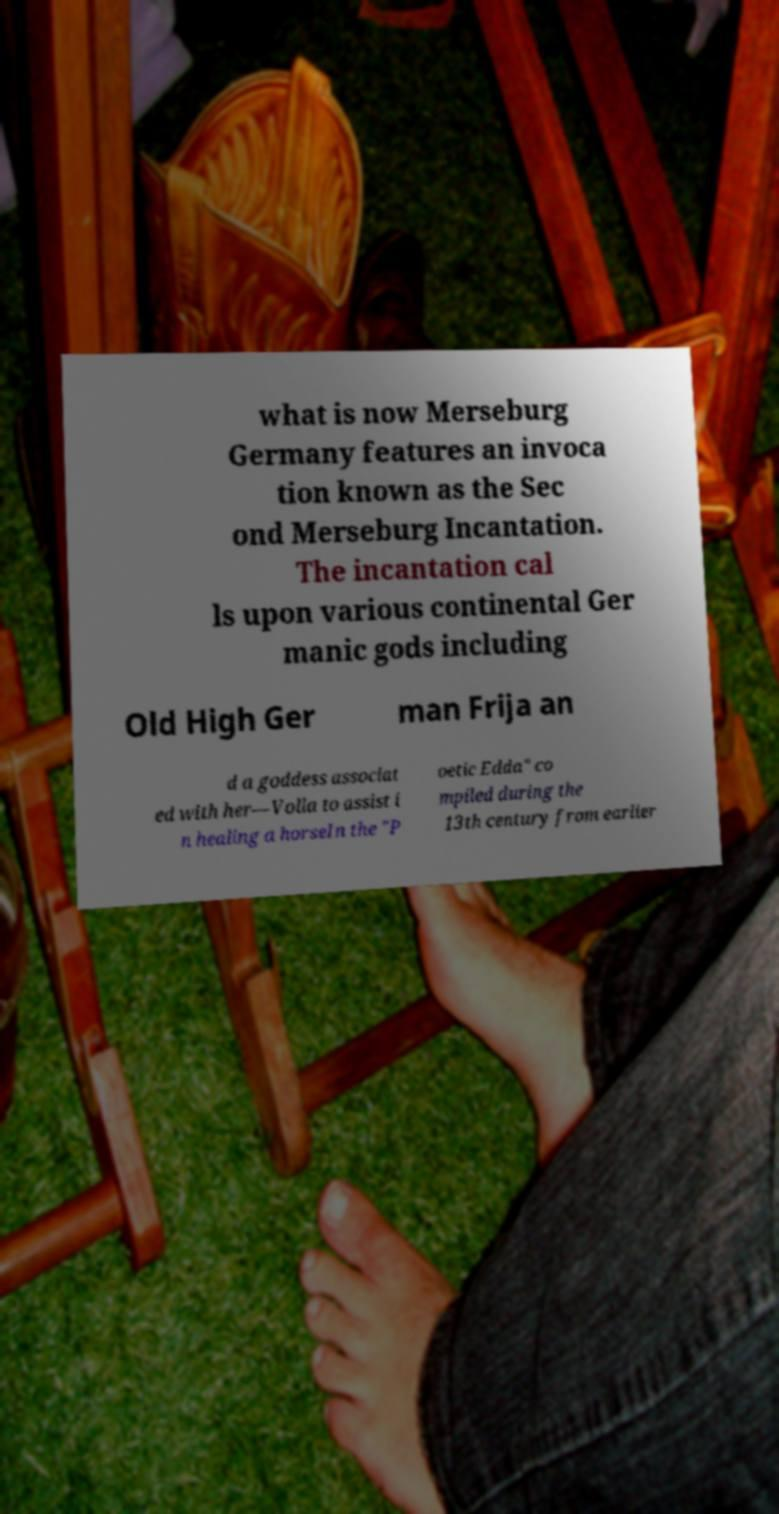For documentation purposes, I need the text within this image transcribed. Could you provide that? what is now Merseburg Germany features an invoca tion known as the Sec ond Merseburg Incantation. The incantation cal ls upon various continental Ger manic gods including Old High Ger man Frija an d a goddess associat ed with her—Volla to assist i n healing a horseIn the "P oetic Edda" co mpiled during the 13th century from earlier 